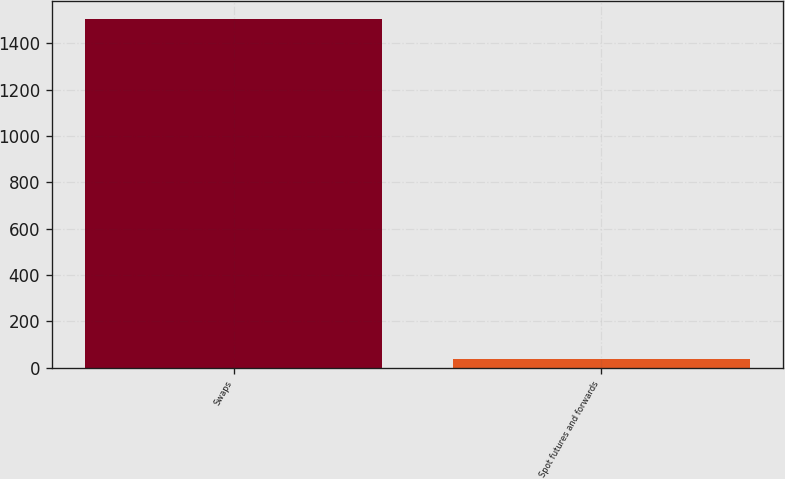<chart> <loc_0><loc_0><loc_500><loc_500><bar_chart><fcel>Swaps<fcel>Spot futures and forwards<nl><fcel>1506.6<fcel>38.5<nl></chart> 